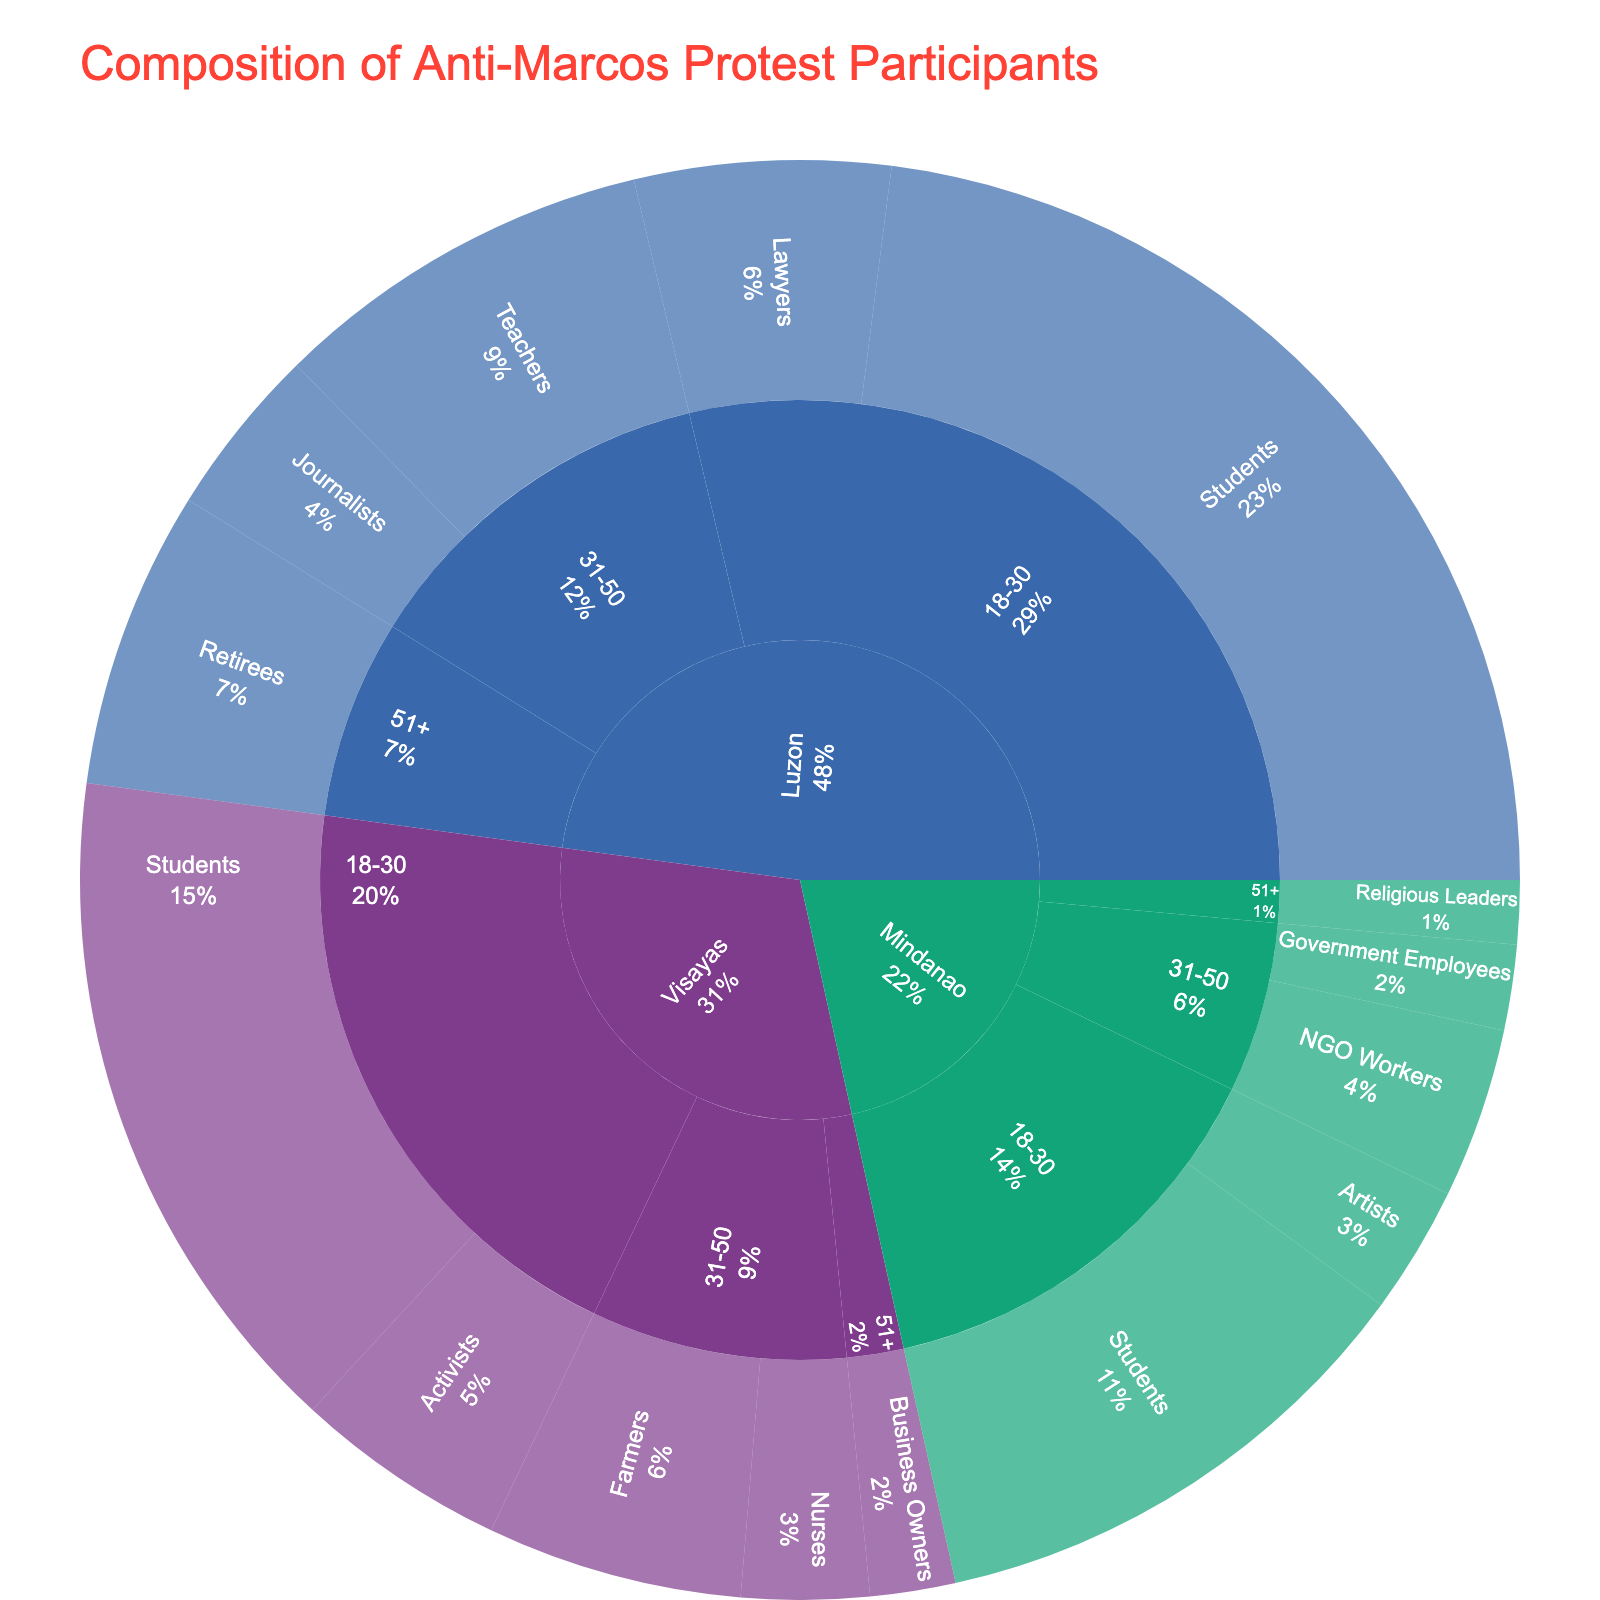Which region has the highest number of participants? To determine the region with the highest number of participants, look at the outermost sections of the sunburst plot and identify which region encompasses the largest cumulative area.
Answer: Luzon What is the total number of Students participating from all regions? Sum the number of student participants from Luzon, Visayas, and Mindanao, which are 1200, 800, and 600 respectively. So, 1200 + 800 + 600 = 2600.
Answer: 2600 How many more Students are there than Teachers in Luzon? Look at the number of students and teachers in Luzon. There are 1200 students and 450 teachers. Subtract the number of teachers from the number of students: 1200 - 450 = 750.
Answer: 750 Which profession has the least participants in Mindanao? Look at the professions within the Mindanao region and find the one with the smallest number of participants. The professions listed are Students (600), Artists (150), NGO Workers (200), Government Employees (100), and Religious Leaders (75). Religious Leaders have the least participants.
Answer: Religious Leaders Are there more Lawyers in Luzon or Activists in Visayas? Compare the number of Lawyers in Luzon (300) with the number of Activists in Visayas (250). Since 300 (Lawyers in Luzon) is greater than 250 (Activists in Visayas), the answer is Lawyers in Luzon.
Answer: Lawyers in Luzon Which Age Group is most represented in the protests across all regions? Sum the participants across all regions for each age group and identify the highest total. Age groups are 18-30, 31-50, and 51+. Add the relevant numbers for each age group:
- 18-30: 1200 (Luzon) + 300 (Lawyers) + 800 (Visayas) + 250 (Activists) + 600 (Mindanao) + 150 (Artists) = 3300
- 31-50: 450 (Teachers) + 200 (Journalists) + 300 (Farmers) + 150 (Nurses) + 200 (NGO Workers) + 100 (Government Employees) = 1400
- 51+: 350 (Retirees) + 100 (Business Owners) + 75 (Religious Leaders) = 525
The 18-30 age group is the most represented.
Answer: 18-30 What percentage of the total participants do Business Owners from Visayas represent? Find the total number of participants first, then calculate the percentage. Total participants are 3375 (sum of all participants). Business Owners in Visayas are 100. The percentage is (100 / 3375) * 100% ≈ 2.96%.
Answer: 2.96% Which profession within the 31-50 age group in Visayas has more participants? Compare the number of participants: Farmers (300) and Nurses (150). Farmers have more participants.
Answer: Farmers Is there a higher number of 18-30 participants in Visayas or Mindanao? Compare the total numbers of 18-30 participants in Visayas (800 + 250 = 1050) and Mindanao (600 + 150 = 750). So, Visayas has the higher number.
Answer: Visayas What fraction of Luzon's participants are Journalists? Find the total number of participants in Luzon and the number of Journalists. Total in Luzon is 1200 + 300 + 450 + 200 + 350 = 2500. The number of Journalists is 200. The fraction is 200/2500, which simplifies to 1/12.5.
Answer: 1/12.5 